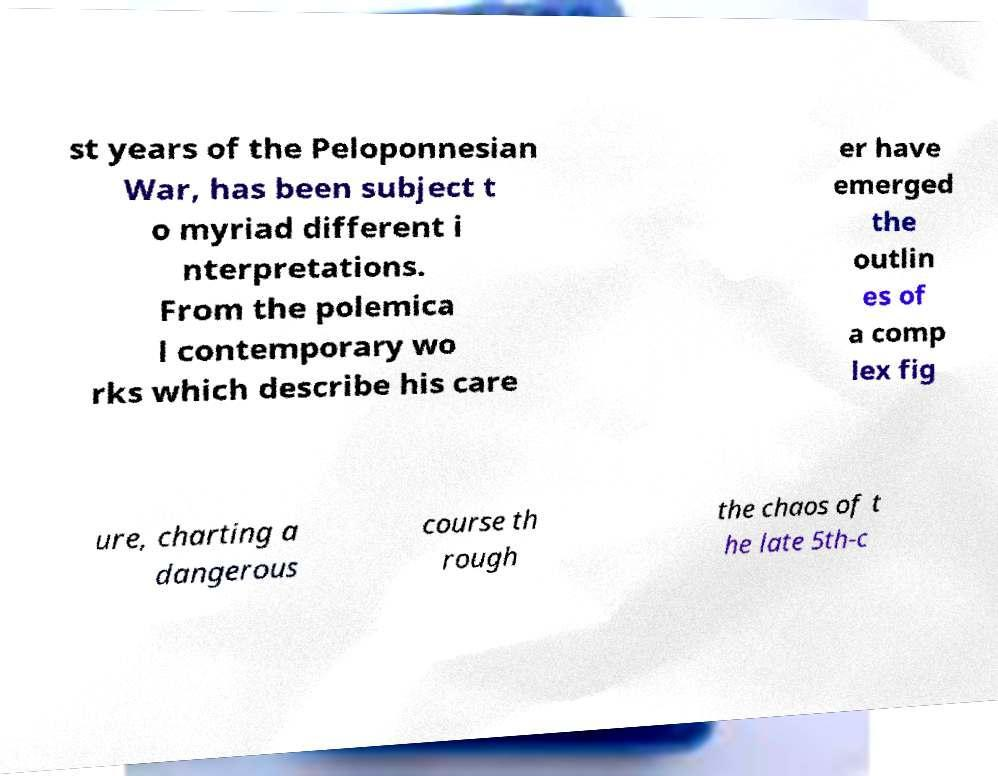There's text embedded in this image that I need extracted. Can you transcribe it verbatim? st years of the Peloponnesian War, has been subject t o myriad different i nterpretations. From the polemica l contemporary wo rks which describe his care er have emerged the outlin es of a comp lex fig ure, charting a dangerous course th rough the chaos of t he late 5th-c 